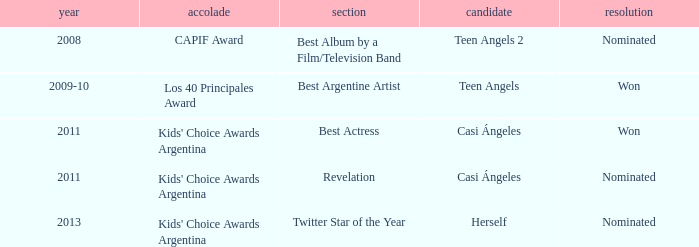Specify the performance that received a capif award nomination. Teen Angels 2. 